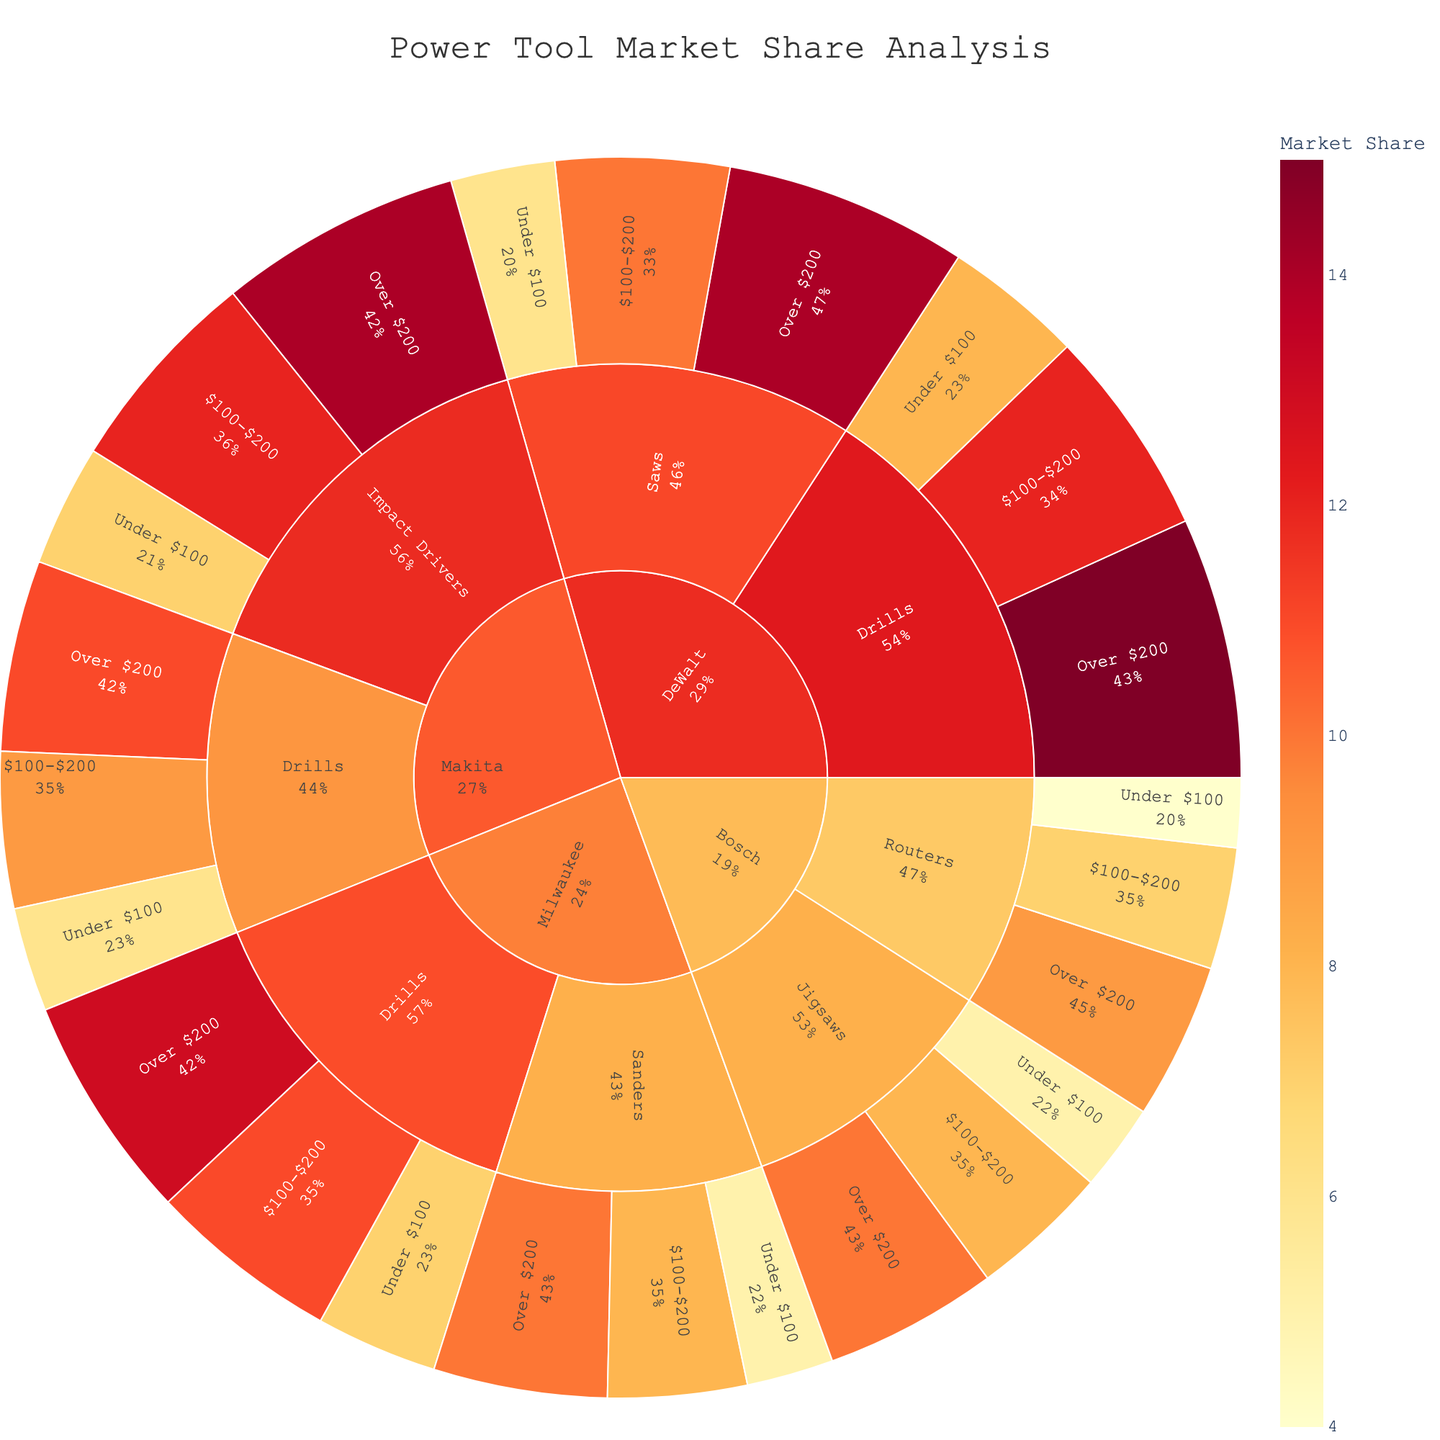What's the overall title of the plot? The title is displayed at the top of the plot, formatted in a larger and bolder font than the other text elements.
Answer: Power Tool Market Share Analysis Which tool type has the highest market share under DeWalt for the price range of $100-$200? Look at the 'DeWalt' manufacturer section, then locate the 'Drills' and 'Saws' tool types within the $100-$200 price range, and compare their market share values.
Answer: Drills What’s the combined market share of DeWalt's drills for all price ranges? Sum up the market shares of DeWalt's drills under each price range: 8 (Under $100) + 12 ($100-$200) + 15 (Over $200).
Answer: 35 Which manufacturer has the highest combined market share for tools priced over $200? Compare the combined market shares for each manufacturer for the 'Over $200' price range by summing their respective tool types: DeWalt (Drills + Saws: 15 + 14 = 29), Milwaukee (Drills + Sanders: 13 + 10 = 23), Makita (Drills + Impact Drivers: 11 + 14 = 25), Bosch (Routers + Jigsaws: 9 + 10 = 19).
Answer: DeWalt Among all the tools priced under $100, which manufacturer has the lowest market share and for which tool type? For all tool types under the 'Under $100' price range, compare market shares across manufacturers: DeWalt (Drills: 8, Saws: 6), Milwaukee (Drills: 7, Sanders: 5), Makita (Drills: 6, Impact Drivers: 7), Bosch (Routers: 4, Jigsaws: 5).
Answer: Bosch, Routers Which tool type does Milwaukee have only a single price range represented? Look at all the tool types under Milwaukee and observe which ones have fewer price range segments. Only 'Sanders' has three price ranges, indicating other types have fewer segments.
Answer: Sanders 